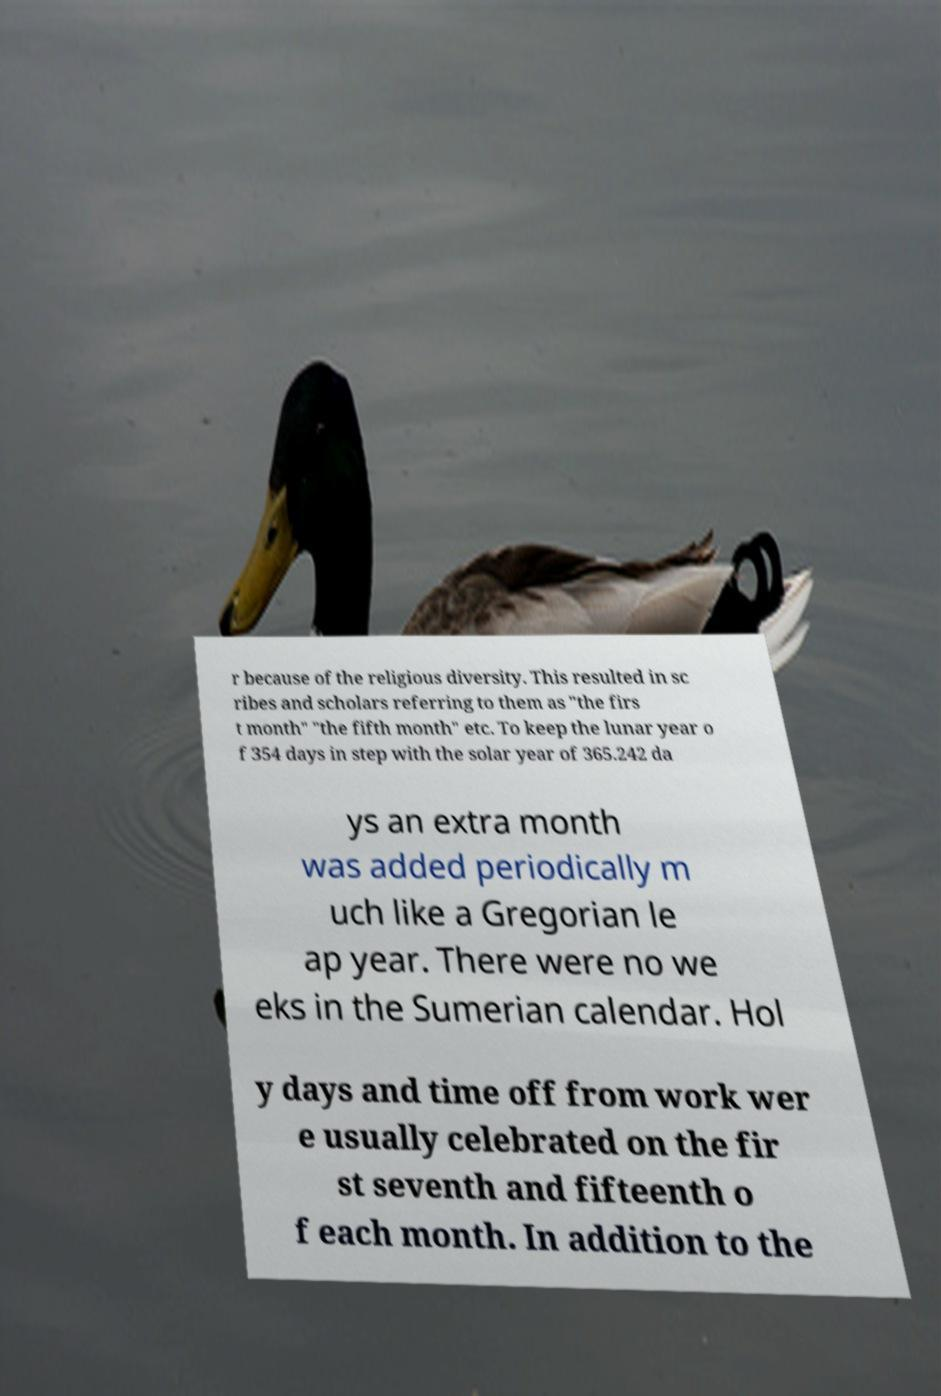There's text embedded in this image that I need extracted. Can you transcribe it verbatim? r because of the religious diversity. This resulted in sc ribes and scholars referring to them as "the firs t month" "the fifth month" etc. To keep the lunar year o f 354 days in step with the solar year of 365.242 da ys an extra month was added periodically m uch like a Gregorian le ap year. There were no we eks in the Sumerian calendar. Hol y days and time off from work wer e usually celebrated on the fir st seventh and fifteenth o f each month. In addition to the 